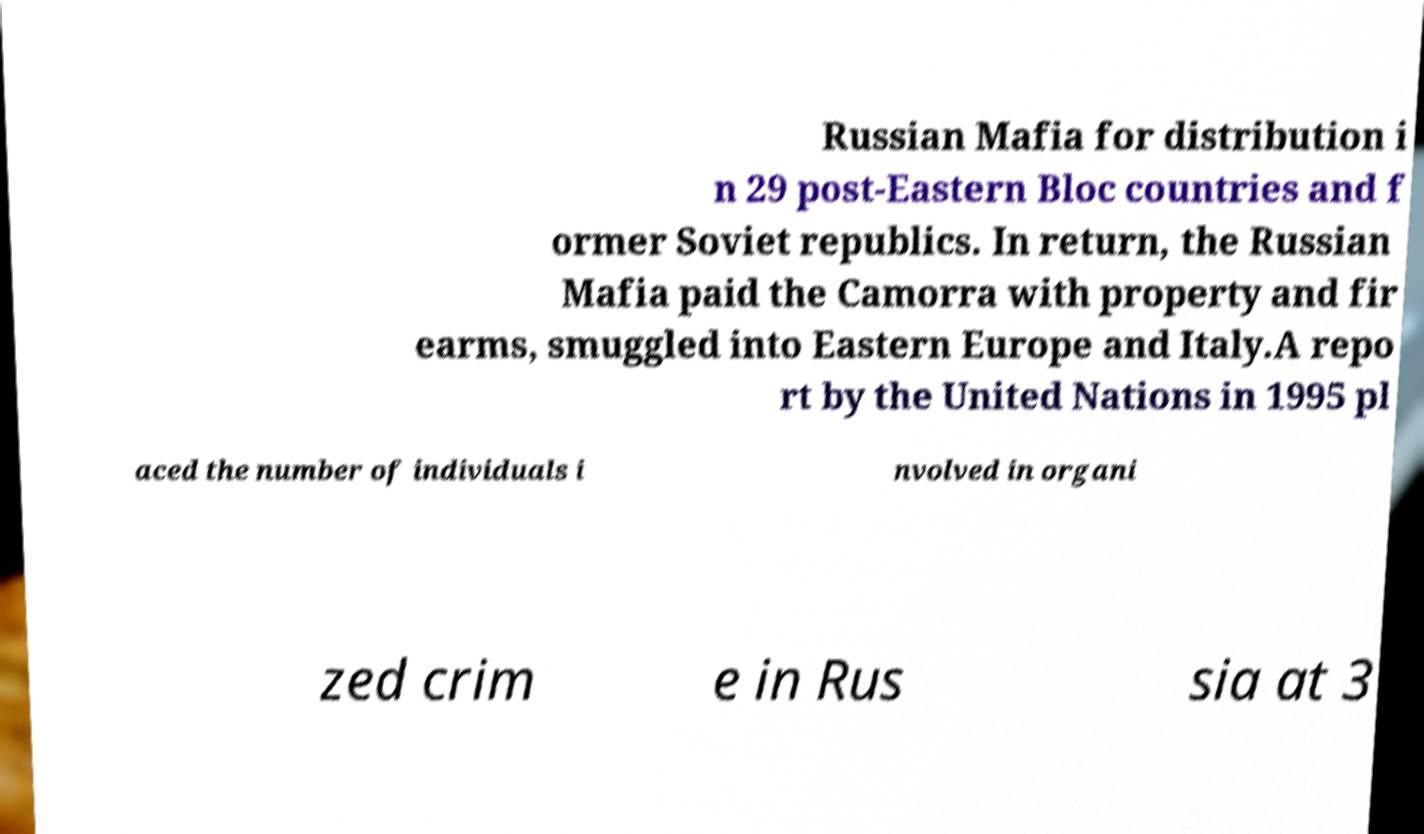Could you extract and type out the text from this image? Russian Mafia for distribution i n 29 post-Eastern Bloc countries and f ormer Soviet republics. In return, the Russian Mafia paid the Camorra with property and fir earms, smuggled into Eastern Europe and Italy.A repo rt by the United Nations in 1995 pl aced the number of individuals i nvolved in organi zed crim e in Rus sia at 3 